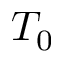<formula> <loc_0><loc_0><loc_500><loc_500>T _ { 0 }</formula> 